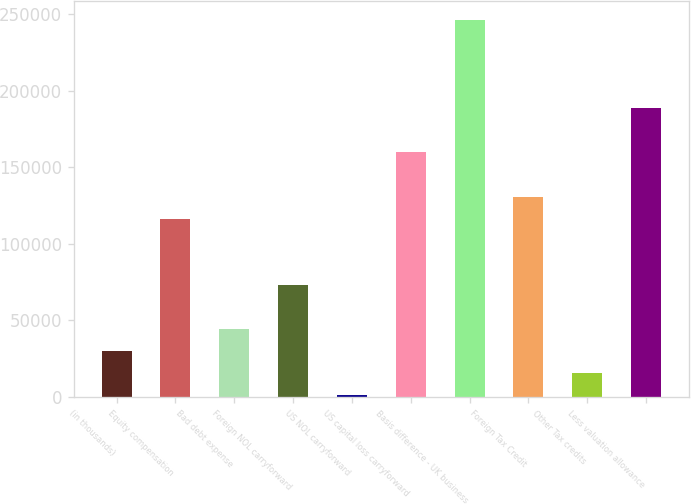Convert chart to OTSL. <chart><loc_0><loc_0><loc_500><loc_500><bar_chart><fcel>(in thousands)<fcel>Equity compensation<fcel>Bad debt expense<fcel>Foreign NOL carryforward<fcel>US NOL carryforward<fcel>US capital loss carryforward<fcel>Basis difference - UK business<fcel>Foreign Tax Credit<fcel>Other Tax credits<fcel>Less valuation allowance<nl><fcel>29906.8<fcel>116378<fcel>44318.7<fcel>73142.5<fcel>1083<fcel>159614<fcel>246085<fcel>130790<fcel>15494.9<fcel>188438<nl></chart> 